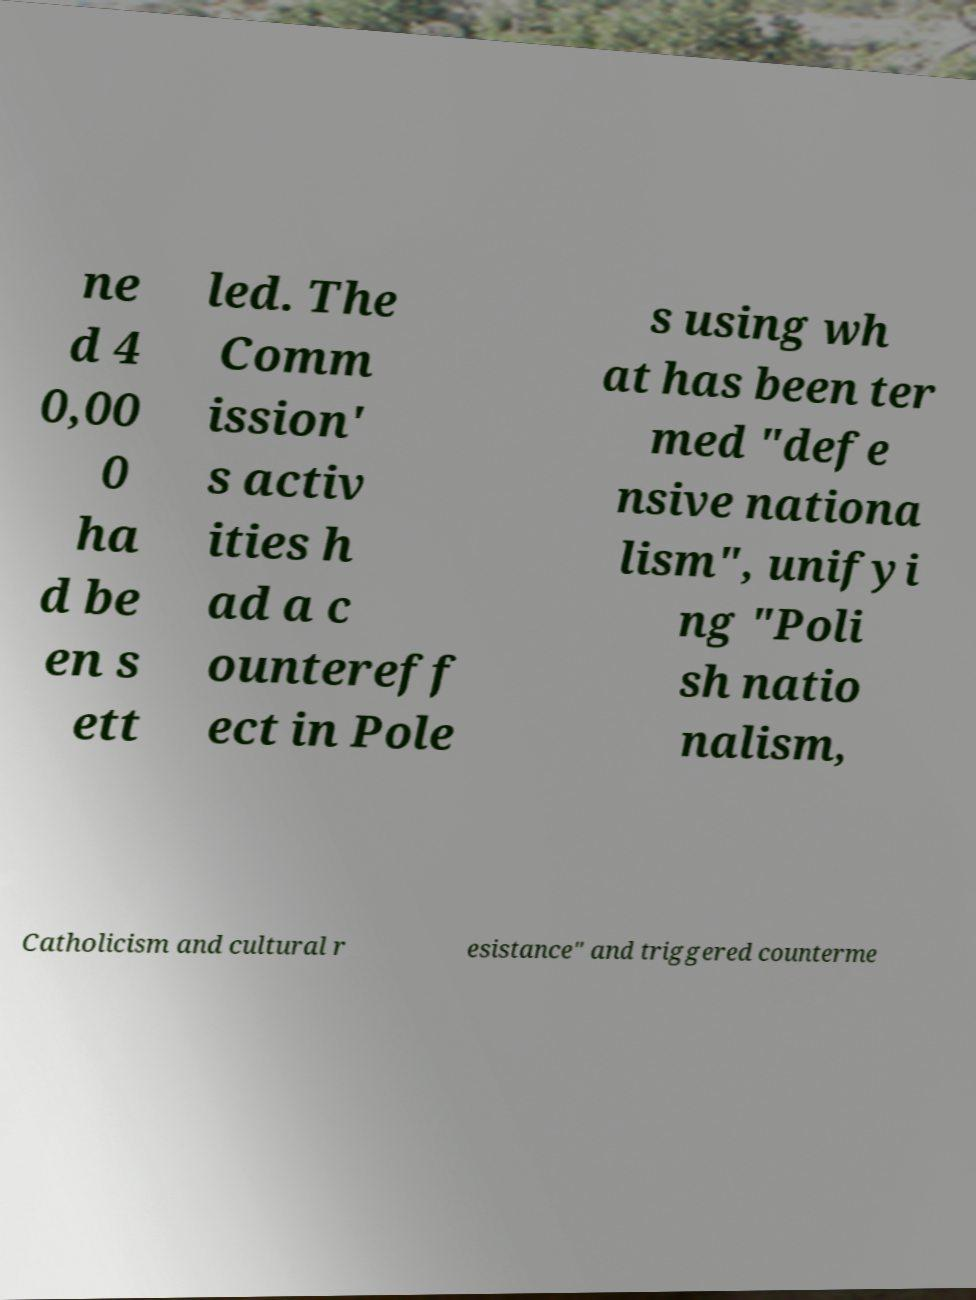Could you assist in decoding the text presented in this image and type it out clearly? ne d 4 0,00 0 ha d be en s ett led. The Comm ission' s activ ities h ad a c ountereff ect in Pole s using wh at has been ter med "defe nsive nationa lism", unifyi ng "Poli sh natio nalism, Catholicism and cultural r esistance" and triggered counterme 